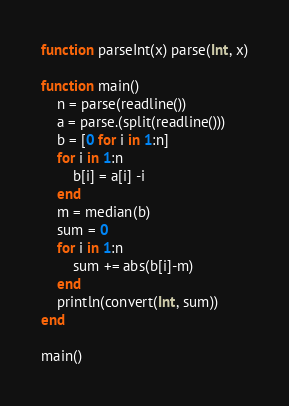Convert code to text. <code><loc_0><loc_0><loc_500><loc_500><_Julia_>function parseInt(x) parse(Int, x)

function main()
	n = parse(readline())
	a = parse.(split(readline()))
	b = [0 for i in 1:n]
	for i in 1:n
		b[i] = a[i] -i
	end
	m = median(b)
	sum = 0
	for i in 1:n
		sum += abs(b[i]-m)
	end
	println(convert(Int, sum))
end

main()</code> 